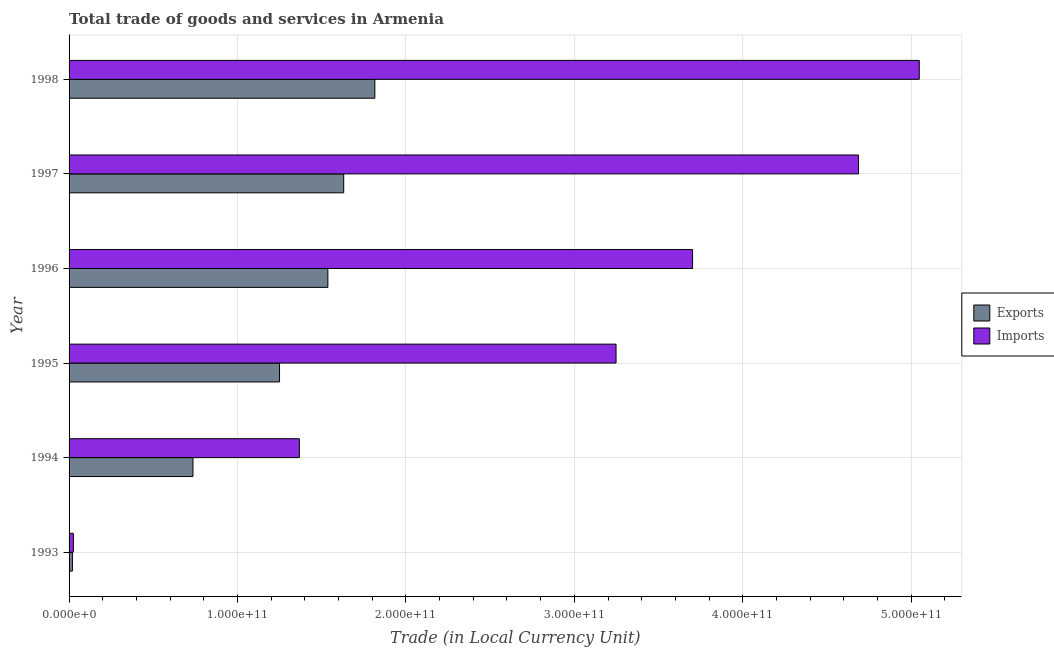How many different coloured bars are there?
Provide a succinct answer. 2. How many groups of bars are there?
Provide a succinct answer. 6. Are the number of bars on each tick of the Y-axis equal?
Make the answer very short. Yes. What is the label of the 4th group of bars from the top?
Provide a short and direct response. 1995. In how many cases, is the number of bars for a given year not equal to the number of legend labels?
Ensure brevity in your answer.  0. What is the imports of goods and services in 1993?
Make the answer very short. 2.56e+09. Across all years, what is the maximum export of goods and services?
Provide a short and direct response. 1.82e+11. Across all years, what is the minimum export of goods and services?
Your answer should be compact. 1.99e+09. What is the total export of goods and services in the graph?
Give a very brief answer. 6.99e+11. What is the difference between the export of goods and services in 1993 and that in 1998?
Your answer should be compact. -1.80e+11. What is the difference between the imports of goods and services in 1997 and the export of goods and services in 1993?
Make the answer very short. 4.67e+11. What is the average export of goods and services per year?
Keep it short and to the point. 1.16e+11. In the year 1998, what is the difference between the export of goods and services and imports of goods and services?
Provide a succinct answer. -3.23e+11. In how many years, is the imports of goods and services greater than 440000000000 LCU?
Your answer should be very brief. 2. What is the ratio of the export of goods and services in 1994 to that in 1995?
Your answer should be compact. 0.59. Is the imports of goods and services in 1995 less than that in 1998?
Your answer should be very brief. Yes. What is the difference between the highest and the second highest export of goods and services?
Offer a very short reply. 1.85e+1. What is the difference between the highest and the lowest export of goods and services?
Your response must be concise. 1.80e+11. What does the 1st bar from the top in 1998 represents?
Your response must be concise. Imports. What does the 1st bar from the bottom in 1993 represents?
Ensure brevity in your answer.  Exports. How many years are there in the graph?
Your answer should be compact. 6. What is the difference between two consecutive major ticks on the X-axis?
Your response must be concise. 1.00e+11. Does the graph contain grids?
Offer a terse response. Yes. What is the title of the graph?
Your answer should be very brief. Total trade of goods and services in Armenia. What is the label or title of the X-axis?
Your answer should be compact. Trade (in Local Currency Unit). What is the Trade (in Local Currency Unit) of Exports in 1993?
Your answer should be very brief. 1.99e+09. What is the Trade (in Local Currency Unit) of Imports in 1993?
Your answer should be compact. 2.56e+09. What is the Trade (in Local Currency Unit) in Exports in 1994?
Offer a terse response. 7.36e+1. What is the Trade (in Local Currency Unit) of Imports in 1994?
Provide a succinct answer. 1.37e+11. What is the Trade (in Local Currency Unit) in Exports in 1995?
Your answer should be very brief. 1.25e+11. What is the Trade (in Local Currency Unit) of Imports in 1995?
Your answer should be very brief. 3.25e+11. What is the Trade (in Local Currency Unit) of Exports in 1996?
Offer a very short reply. 1.54e+11. What is the Trade (in Local Currency Unit) in Imports in 1996?
Your answer should be compact. 3.70e+11. What is the Trade (in Local Currency Unit) of Exports in 1997?
Your response must be concise. 1.63e+11. What is the Trade (in Local Currency Unit) of Imports in 1997?
Make the answer very short. 4.69e+11. What is the Trade (in Local Currency Unit) in Exports in 1998?
Give a very brief answer. 1.82e+11. What is the Trade (in Local Currency Unit) of Imports in 1998?
Provide a short and direct response. 5.05e+11. Across all years, what is the maximum Trade (in Local Currency Unit) in Exports?
Keep it short and to the point. 1.82e+11. Across all years, what is the maximum Trade (in Local Currency Unit) in Imports?
Offer a very short reply. 5.05e+11. Across all years, what is the minimum Trade (in Local Currency Unit) of Exports?
Provide a short and direct response. 1.99e+09. Across all years, what is the minimum Trade (in Local Currency Unit) of Imports?
Your answer should be compact. 2.56e+09. What is the total Trade (in Local Currency Unit) in Exports in the graph?
Provide a short and direct response. 6.99e+11. What is the total Trade (in Local Currency Unit) in Imports in the graph?
Your answer should be compact. 1.81e+12. What is the difference between the Trade (in Local Currency Unit) in Exports in 1993 and that in 1994?
Offer a terse response. -7.16e+1. What is the difference between the Trade (in Local Currency Unit) of Imports in 1993 and that in 1994?
Give a very brief answer. -1.34e+11. What is the difference between the Trade (in Local Currency Unit) of Exports in 1993 and that in 1995?
Provide a succinct answer. -1.23e+11. What is the difference between the Trade (in Local Currency Unit) in Imports in 1993 and that in 1995?
Provide a short and direct response. -3.22e+11. What is the difference between the Trade (in Local Currency Unit) of Exports in 1993 and that in 1996?
Your response must be concise. -1.52e+11. What is the difference between the Trade (in Local Currency Unit) in Imports in 1993 and that in 1996?
Make the answer very short. -3.68e+11. What is the difference between the Trade (in Local Currency Unit) of Exports in 1993 and that in 1997?
Make the answer very short. -1.61e+11. What is the difference between the Trade (in Local Currency Unit) in Imports in 1993 and that in 1997?
Give a very brief answer. -4.66e+11. What is the difference between the Trade (in Local Currency Unit) in Exports in 1993 and that in 1998?
Offer a terse response. -1.80e+11. What is the difference between the Trade (in Local Currency Unit) of Imports in 1993 and that in 1998?
Provide a succinct answer. -5.02e+11. What is the difference between the Trade (in Local Currency Unit) in Exports in 1994 and that in 1995?
Keep it short and to the point. -5.14e+1. What is the difference between the Trade (in Local Currency Unit) in Imports in 1994 and that in 1995?
Your response must be concise. -1.88e+11. What is the difference between the Trade (in Local Currency Unit) of Exports in 1994 and that in 1996?
Offer a very short reply. -8.01e+1. What is the difference between the Trade (in Local Currency Unit) of Imports in 1994 and that in 1996?
Keep it short and to the point. -2.33e+11. What is the difference between the Trade (in Local Currency Unit) in Exports in 1994 and that in 1997?
Make the answer very short. -8.95e+1. What is the difference between the Trade (in Local Currency Unit) of Imports in 1994 and that in 1997?
Offer a very short reply. -3.32e+11. What is the difference between the Trade (in Local Currency Unit) of Exports in 1994 and that in 1998?
Offer a very short reply. -1.08e+11. What is the difference between the Trade (in Local Currency Unit) in Imports in 1994 and that in 1998?
Your response must be concise. -3.68e+11. What is the difference between the Trade (in Local Currency Unit) in Exports in 1995 and that in 1996?
Provide a succinct answer. -2.87e+1. What is the difference between the Trade (in Local Currency Unit) in Imports in 1995 and that in 1996?
Your response must be concise. -4.54e+1. What is the difference between the Trade (in Local Currency Unit) in Exports in 1995 and that in 1997?
Your response must be concise. -3.81e+1. What is the difference between the Trade (in Local Currency Unit) of Imports in 1995 and that in 1997?
Provide a short and direct response. -1.44e+11. What is the difference between the Trade (in Local Currency Unit) of Exports in 1995 and that in 1998?
Offer a very short reply. -5.66e+1. What is the difference between the Trade (in Local Currency Unit) in Imports in 1995 and that in 1998?
Your answer should be very brief. -1.80e+11. What is the difference between the Trade (in Local Currency Unit) of Exports in 1996 and that in 1997?
Offer a very short reply. -9.40e+09. What is the difference between the Trade (in Local Currency Unit) in Imports in 1996 and that in 1997?
Provide a short and direct response. -9.85e+1. What is the difference between the Trade (in Local Currency Unit) in Exports in 1996 and that in 1998?
Offer a very short reply. -2.79e+1. What is the difference between the Trade (in Local Currency Unit) of Imports in 1996 and that in 1998?
Give a very brief answer. -1.35e+11. What is the difference between the Trade (in Local Currency Unit) in Exports in 1997 and that in 1998?
Ensure brevity in your answer.  -1.85e+1. What is the difference between the Trade (in Local Currency Unit) of Imports in 1997 and that in 1998?
Offer a very short reply. -3.61e+1. What is the difference between the Trade (in Local Currency Unit) of Exports in 1993 and the Trade (in Local Currency Unit) of Imports in 1994?
Give a very brief answer. -1.35e+11. What is the difference between the Trade (in Local Currency Unit) in Exports in 1993 and the Trade (in Local Currency Unit) in Imports in 1995?
Offer a terse response. -3.23e+11. What is the difference between the Trade (in Local Currency Unit) in Exports in 1993 and the Trade (in Local Currency Unit) in Imports in 1996?
Offer a very short reply. -3.68e+11. What is the difference between the Trade (in Local Currency Unit) in Exports in 1993 and the Trade (in Local Currency Unit) in Imports in 1997?
Offer a very short reply. -4.67e+11. What is the difference between the Trade (in Local Currency Unit) of Exports in 1993 and the Trade (in Local Currency Unit) of Imports in 1998?
Ensure brevity in your answer.  -5.03e+11. What is the difference between the Trade (in Local Currency Unit) in Exports in 1994 and the Trade (in Local Currency Unit) in Imports in 1995?
Provide a succinct answer. -2.51e+11. What is the difference between the Trade (in Local Currency Unit) of Exports in 1994 and the Trade (in Local Currency Unit) of Imports in 1996?
Ensure brevity in your answer.  -2.97e+11. What is the difference between the Trade (in Local Currency Unit) in Exports in 1994 and the Trade (in Local Currency Unit) in Imports in 1997?
Give a very brief answer. -3.95e+11. What is the difference between the Trade (in Local Currency Unit) in Exports in 1994 and the Trade (in Local Currency Unit) in Imports in 1998?
Make the answer very short. -4.31e+11. What is the difference between the Trade (in Local Currency Unit) of Exports in 1995 and the Trade (in Local Currency Unit) of Imports in 1996?
Provide a succinct answer. -2.45e+11. What is the difference between the Trade (in Local Currency Unit) in Exports in 1995 and the Trade (in Local Currency Unit) in Imports in 1997?
Provide a succinct answer. -3.44e+11. What is the difference between the Trade (in Local Currency Unit) in Exports in 1995 and the Trade (in Local Currency Unit) in Imports in 1998?
Offer a terse response. -3.80e+11. What is the difference between the Trade (in Local Currency Unit) in Exports in 1996 and the Trade (in Local Currency Unit) in Imports in 1997?
Offer a terse response. -3.15e+11. What is the difference between the Trade (in Local Currency Unit) of Exports in 1996 and the Trade (in Local Currency Unit) of Imports in 1998?
Your response must be concise. -3.51e+11. What is the difference between the Trade (in Local Currency Unit) of Exports in 1997 and the Trade (in Local Currency Unit) of Imports in 1998?
Offer a very short reply. -3.42e+11. What is the average Trade (in Local Currency Unit) in Exports per year?
Offer a terse response. 1.16e+11. What is the average Trade (in Local Currency Unit) of Imports per year?
Make the answer very short. 3.01e+11. In the year 1993, what is the difference between the Trade (in Local Currency Unit) in Exports and Trade (in Local Currency Unit) in Imports?
Make the answer very short. -5.71e+08. In the year 1994, what is the difference between the Trade (in Local Currency Unit) in Exports and Trade (in Local Currency Unit) in Imports?
Make the answer very short. -6.32e+1. In the year 1995, what is the difference between the Trade (in Local Currency Unit) in Exports and Trade (in Local Currency Unit) in Imports?
Offer a terse response. -2.00e+11. In the year 1996, what is the difference between the Trade (in Local Currency Unit) of Exports and Trade (in Local Currency Unit) of Imports?
Your answer should be very brief. -2.17e+11. In the year 1997, what is the difference between the Trade (in Local Currency Unit) in Exports and Trade (in Local Currency Unit) in Imports?
Give a very brief answer. -3.06e+11. In the year 1998, what is the difference between the Trade (in Local Currency Unit) of Exports and Trade (in Local Currency Unit) of Imports?
Provide a succinct answer. -3.23e+11. What is the ratio of the Trade (in Local Currency Unit) in Exports in 1993 to that in 1994?
Ensure brevity in your answer.  0.03. What is the ratio of the Trade (in Local Currency Unit) of Imports in 1993 to that in 1994?
Give a very brief answer. 0.02. What is the ratio of the Trade (in Local Currency Unit) in Exports in 1993 to that in 1995?
Your response must be concise. 0.02. What is the ratio of the Trade (in Local Currency Unit) of Imports in 1993 to that in 1995?
Make the answer very short. 0.01. What is the ratio of the Trade (in Local Currency Unit) in Exports in 1993 to that in 1996?
Your answer should be very brief. 0.01. What is the ratio of the Trade (in Local Currency Unit) in Imports in 1993 to that in 1996?
Your response must be concise. 0.01. What is the ratio of the Trade (in Local Currency Unit) in Exports in 1993 to that in 1997?
Your answer should be compact. 0.01. What is the ratio of the Trade (in Local Currency Unit) in Imports in 1993 to that in 1997?
Your response must be concise. 0.01. What is the ratio of the Trade (in Local Currency Unit) in Exports in 1993 to that in 1998?
Your response must be concise. 0.01. What is the ratio of the Trade (in Local Currency Unit) in Imports in 1993 to that in 1998?
Your response must be concise. 0.01. What is the ratio of the Trade (in Local Currency Unit) in Exports in 1994 to that in 1995?
Offer a terse response. 0.59. What is the ratio of the Trade (in Local Currency Unit) in Imports in 1994 to that in 1995?
Your response must be concise. 0.42. What is the ratio of the Trade (in Local Currency Unit) of Exports in 1994 to that in 1996?
Ensure brevity in your answer.  0.48. What is the ratio of the Trade (in Local Currency Unit) of Imports in 1994 to that in 1996?
Provide a short and direct response. 0.37. What is the ratio of the Trade (in Local Currency Unit) in Exports in 1994 to that in 1997?
Provide a short and direct response. 0.45. What is the ratio of the Trade (in Local Currency Unit) of Imports in 1994 to that in 1997?
Your response must be concise. 0.29. What is the ratio of the Trade (in Local Currency Unit) of Exports in 1994 to that in 1998?
Ensure brevity in your answer.  0.41. What is the ratio of the Trade (in Local Currency Unit) in Imports in 1994 to that in 1998?
Give a very brief answer. 0.27. What is the ratio of the Trade (in Local Currency Unit) in Exports in 1995 to that in 1996?
Give a very brief answer. 0.81. What is the ratio of the Trade (in Local Currency Unit) of Imports in 1995 to that in 1996?
Provide a succinct answer. 0.88. What is the ratio of the Trade (in Local Currency Unit) in Exports in 1995 to that in 1997?
Keep it short and to the point. 0.77. What is the ratio of the Trade (in Local Currency Unit) in Imports in 1995 to that in 1997?
Offer a very short reply. 0.69. What is the ratio of the Trade (in Local Currency Unit) of Exports in 1995 to that in 1998?
Keep it short and to the point. 0.69. What is the ratio of the Trade (in Local Currency Unit) in Imports in 1995 to that in 1998?
Offer a terse response. 0.64. What is the ratio of the Trade (in Local Currency Unit) in Exports in 1996 to that in 1997?
Offer a terse response. 0.94. What is the ratio of the Trade (in Local Currency Unit) of Imports in 1996 to that in 1997?
Your answer should be very brief. 0.79. What is the ratio of the Trade (in Local Currency Unit) of Exports in 1996 to that in 1998?
Your response must be concise. 0.85. What is the ratio of the Trade (in Local Currency Unit) in Imports in 1996 to that in 1998?
Your answer should be very brief. 0.73. What is the ratio of the Trade (in Local Currency Unit) of Exports in 1997 to that in 1998?
Provide a short and direct response. 0.9. What is the ratio of the Trade (in Local Currency Unit) of Imports in 1997 to that in 1998?
Ensure brevity in your answer.  0.93. What is the difference between the highest and the second highest Trade (in Local Currency Unit) of Exports?
Offer a terse response. 1.85e+1. What is the difference between the highest and the second highest Trade (in Local Currency Unit) in Imports?
Your response must be concise. 3.61e+1. What is the difference between the highest and the lowest Trade (in Local Currency Unit) in Exports?
Make the answer very short. 1.80e+11. What is the difference between the highest and the lowest Trade (in Local Currency Unit) in Imports?
Your answer should be very brief. 5.02e+11. 